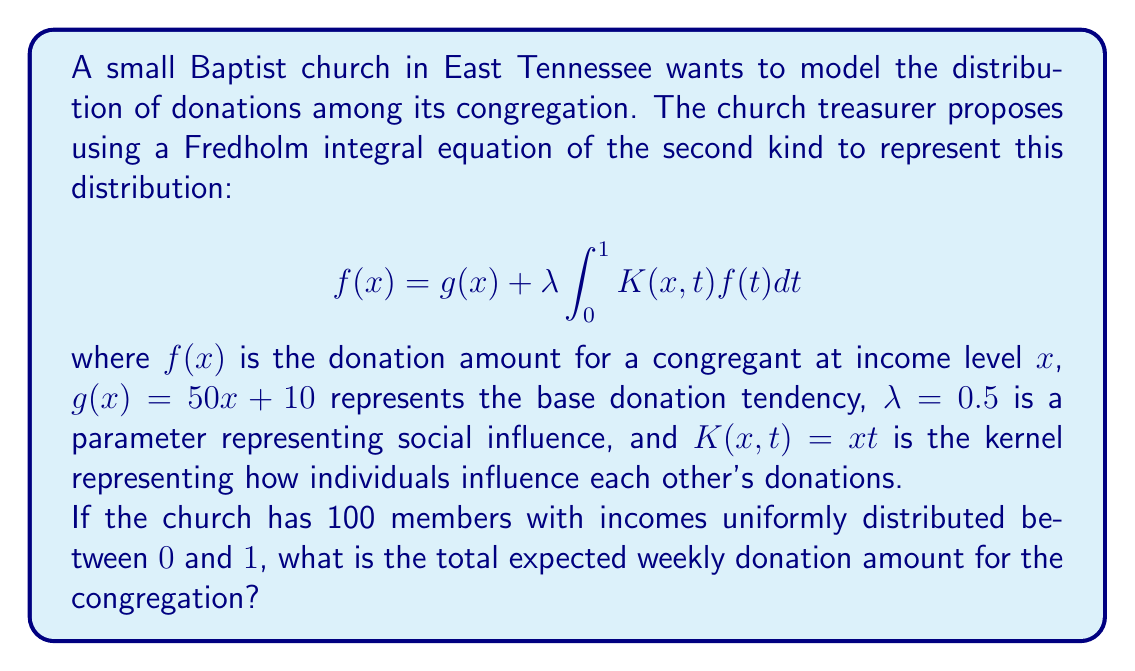Can you solve this math problem? To solve this problem, we need to follow these steps:

1) First, we need to solve the Fredholm integral equation to find $f(x)$. We can do this by assuming $f(x)$ has the form $f(x) = ax + b$ and substituting it into the equation.

2) Substituting $f(x) = ax + b$ into the equation:

   $ax + b = 50x + 10 + 0.5 \int_0^1 xt(at + b)dt$

3) Simplify the integral:

   $ax + b = 50x + 10 + 0.5a \int_0^1 xt^2dt + 0.5b \int_0^1 xtdt$

4) Solve the integrals:

   $\int_0^1 xt^2dt = \frac{x}{3}$ and $\int_0^1 xtdt = \frac{x}{2}$

5) Substitute back:

   $ax + b = 50x + 10 + 0.5a(\frac{x}{3}) + 0.5b(\frac{x}{2})$

6) Equate coefficients of $x$ and constants:

   $a = 50 + \frac{a}{6} + \frac{b}{4}$
   $b = 10$

7) Solve these equations:

   $b = 10$
   $a = 60 + \frac{5}{2} = 62.5$

8) Therefore, $f(x) = 62.5x + 10$

9) To find the total expected donation, we need to integrate $f(x)$ over the income distribution and multiply by the number of members:

   Total donation = $100 \int_0^1 (62.5x + 10)dx$

10) Solve the integral:

    $100 [\frac{62.5x^2}{2} + 10x]_0^1 = 100(31.25 + 10) = 4125$

Therefore, the total expected weekly donation is $4125.
Answer: $4125 